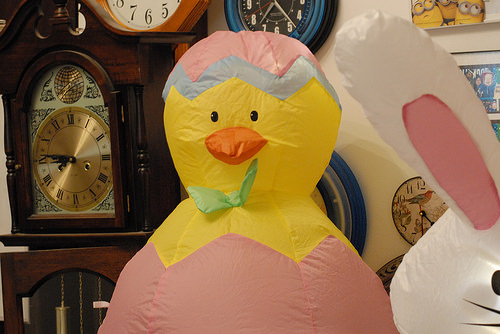<image>
Can you confirm if the clock is in front of the decoration? No. The clock is not in front of the decoration. The spatial positioning shows a different relationship between these objects. 